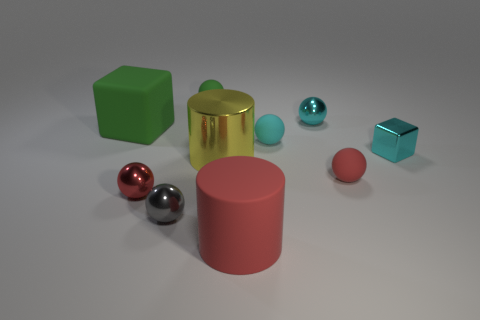Subtract all yellow cubes. How many red balls are left? 2 Subtract all gray balls. How many balls are left? 5 Subtract all green balls. How many balls are left? 5 Subtract all red spheres. Subtract all yellow blocks. How many spheres are left? 4 Subtract all spheres. How many objects are left? 4 Add 7 red cylinders. How many red cylinders are left? 8 Add 4 rubber things. How many rubber things exist? 9 Subtract 0 blue cylinders. How many objects are left? 10 Subtract all green metallic cylinders. Subtract all large red matte cylinders. How many objects are left? 9 